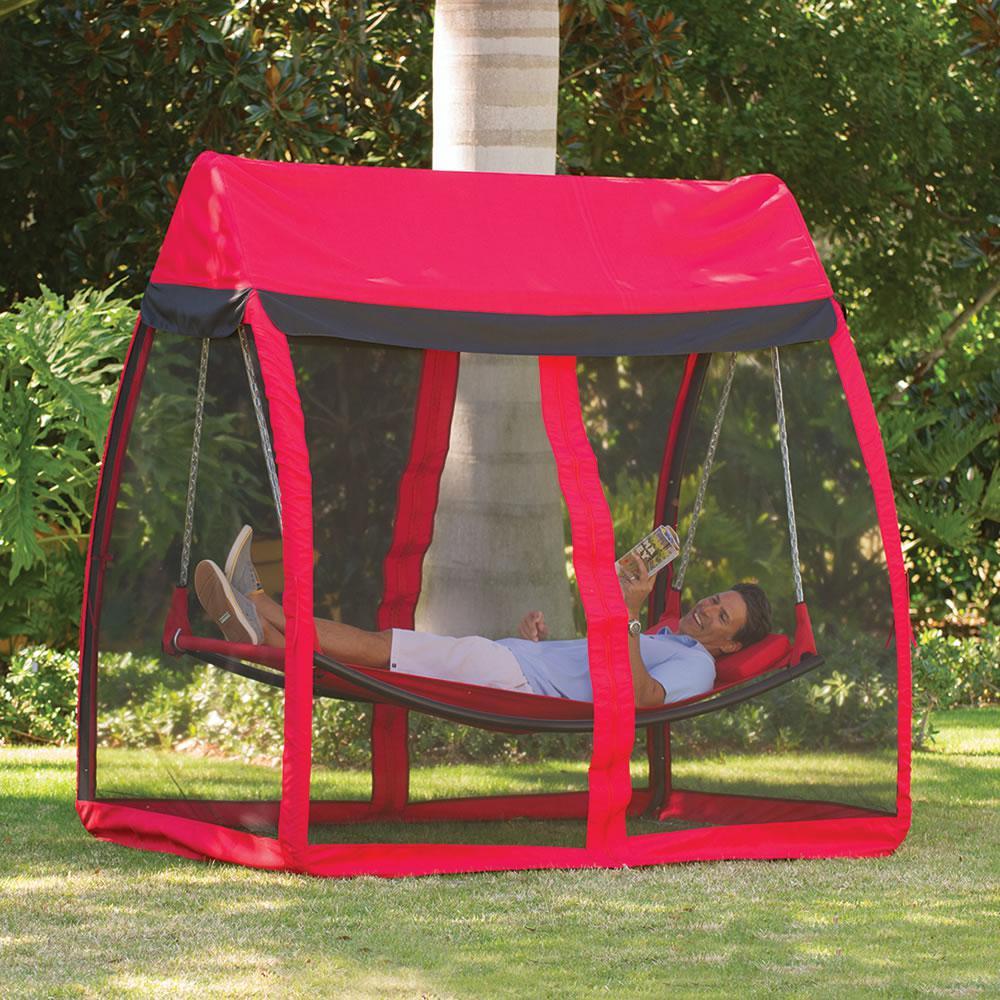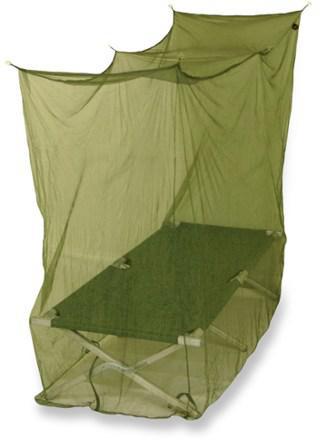The first image is the image on the left, the second image is the image on the right. For the images displayed, is the sentence "There is grass visible on one of the images." factually correct? Answer yes or no. Yes. The first image is the image on the left, the second image is the image on the right. For the images displayed, is the sentence "there is a person in one of the images" factually correct? Answer yes or no. Yes. 